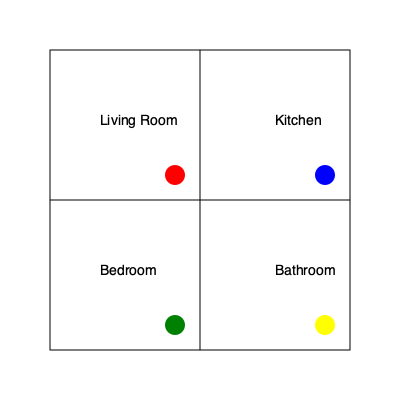In the given floor plan of a house, which room would be the most suitable location for setting up a pet feeding station, considering factors such as cleanliness, accessibility, and minimal disruption to daily activities? To determine the best location for a pet feeding station, let's analyze each room:

1. Living Room (top-left, red circle):
   - Pros: Central location, easily accessible
   - Cons: High traffic area, potential mess on carpets or furniture

2. Kitchen (top-right, blue circle):
   - Pros: Easy to clean floors, close to food storage
   - Cons: Food preparation area, potential hygiene concerns

3. Bedroom (bottom-left, green circle):
   - Pros: Quiet, less foot traffic
   - Cons: Far from living areas, potential mess on carpets

4. Bathroom (bottom-right, yellow circle):
   - Pros: Easy to clean floors, contained space
   - Cons: Limited space, less comfortable for pets

Considering these factors:
- The kitchen is the most suitable location due to its easy-to-clean floors and proximity to food storage.
- It allows for quick cleanup of any spills or messes.
- The kitchen is a common area where pet owners spend time, making it convenient for monitoring and refilling.
- Being close to the living room ensures the pets don't feel isolated during feeding times.

While there might be concerns about hygiene, these can be mitigated by designating a specific corner away from food preparation areas and maintaining a regular cleaning routine.
Answer: Kitchen 